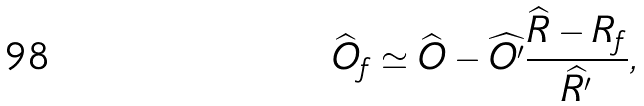<formula> <loc_0><loc_0><loc_500><loc_500>\widehat { O } _ { f } \simeq \widehat { O } - \widehat { O ^ { \prime } } \frac { \widehat { R } - R _ { f } } { \widehat { R ^ { \prime } } } ,</formula> 